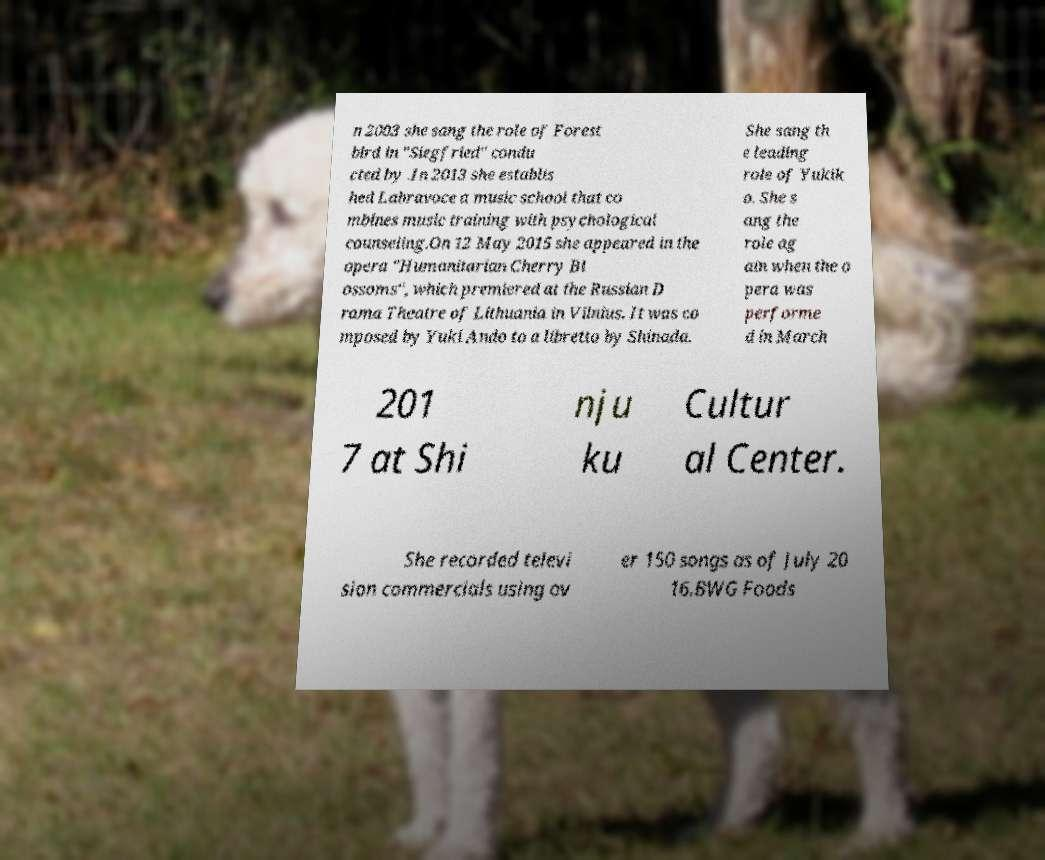Please identify and transcribe the text found in this image. n 2003 she sang the role of Forest bird in "Siegfried" condu cted by .In 2013 she establis hed Labravoce a music school that co mbines music training with psychological counseling.On 12 May 2015 she appeared in the opera "Humanitarian Cherry Bl ossoms", which premiered at the Russian D rama Theatre of Lithuania in Vilnius. It was co mposed by Yuki Ando to a libretto by Shinada. She sang th e leading role of Yukik o. She s ang the role ag ain when the o pera was performe d in March 201 7 at Shi nju ku Cultur al Center. She recorded televi sion commercials using ov er 150 songs as of July 20 16.BWG Foods 